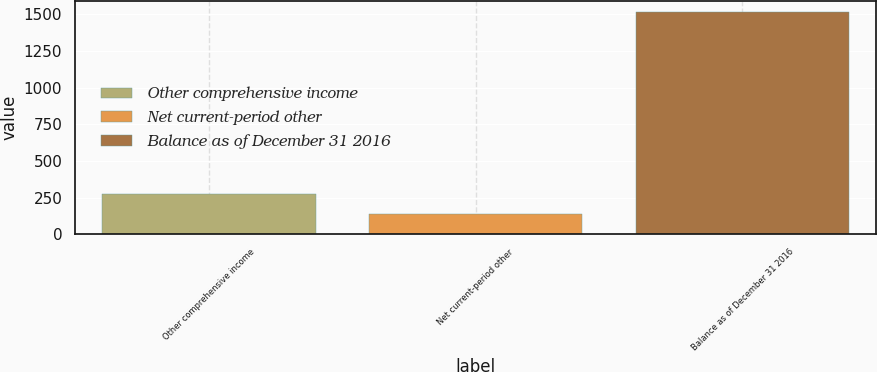Convert chart to OTSL. <chart><loc_0><loc_0><loc_500><loc_500><bar_chart><fcel>Other comprehensive income<fcel>Net current-period other<fcel>Balance as of December 31 2016<nl><fcel>272.8<fcel>135<fcel>1513<nl></chart> 